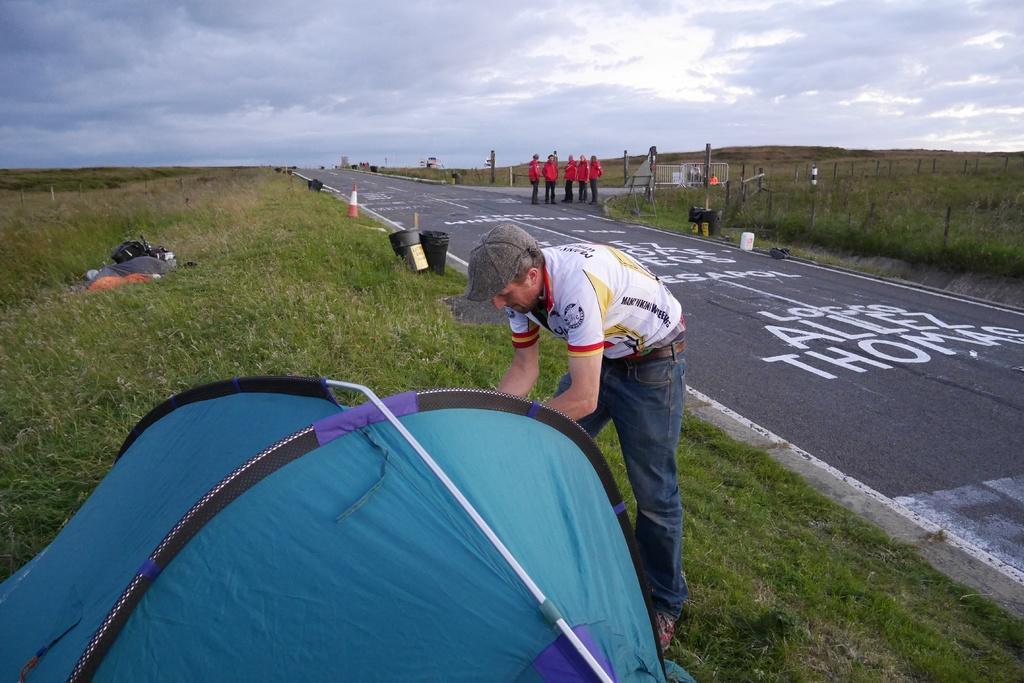Could you give a brief overview of what you see in this image? In this picture I can see group of people are standing. This person is wearing a cap, t-shirt and jeans. Here I can see white lines and something written on the road. In the background I can see grass, traffic cones, poles and the sky. I can see some other objects over here. 